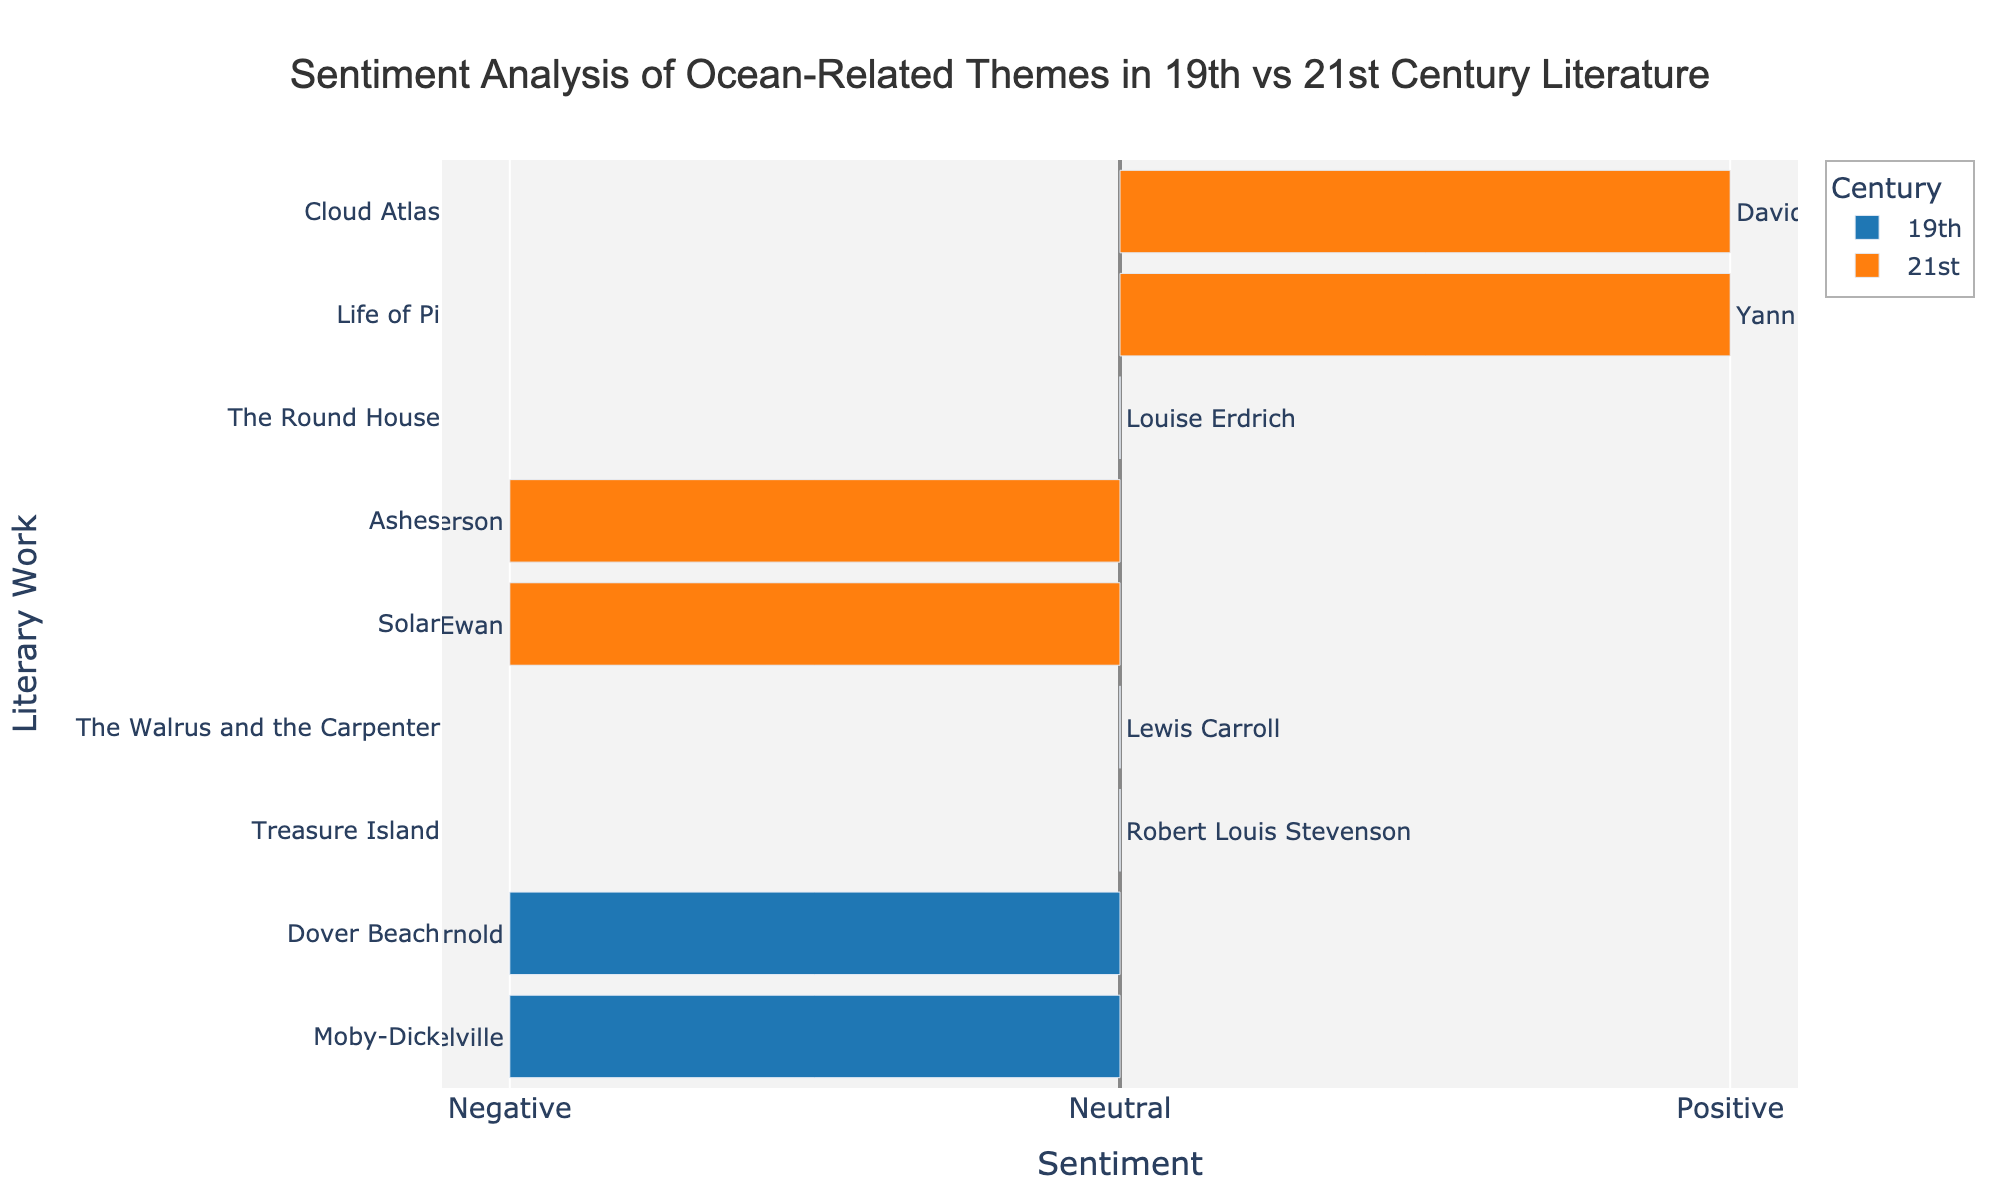What is the sentiment of "Moby-Dick"? "Moby-Dick" is represented on the chart with a bar extending to the left side of the origin point, indicating a negative sentiment as per the plot's x-axis legend.
Answer: Negative Which 21st-century literary work has a positive sentiment? The bars for 21st-century works extending to the right (positive side) include "Life of Pi" and "Cloud Atlas."
Answer: "Life of Pi" and "Cloud Atlas" Are there any 21st-century works with a neutral sentiment? Yes, the 21st-century work "The Round House" has a bar at the neutral point on the x-axis, indicating a neutral sentiment.
Answer: "The Round House" Compare the sentiments of "Moby-Dick" and "Life of Pi". Which has a more positive sentiment? "Moby-Dick" has a bar extending to the left indicating negative sentiment, whereas "Life of Pi" has a bar extending to the right indicating positive sentiment. "Life of Pi" thus has a more positive sentiment.
Answer: "Life of Pi" What is the total number of literary works from the 19th century? By counting the unique bars (works) labeled for the 19th century on the y-axis, a total of 4 works can be observed: "Moby-Dick," "Treasure Island," "Dover Beach," and "The Walrus and the Carpenter."
Answer: 4 Which century has more works with negative sentiment? Observing the bars extending to the left from the origin point, the 19th century has 2 negative works ("Moby-Dick," "Dover Beach") and the 21st century also has 2 negative works ("Solar," "Ashes"). Both centuries have an equal number of negative works.
Answer: Both centuries have equal negative works What is the average sentiment value of 21st-century literature works? 21st-century works have sentiment values of 1 ("Life of Pi"), -1 ("Solar"), 1 ("Cloud Atlas"), 0 ("The Round House"), and -1 ("Ashes"). The sum is 1 + (-1) + 1 + 0 + (-1) = 0. With 5 works, the average is 0/5 = 0.
Answer: 0 Which 19th-century work has a neutral sentiment and is also the shortest in bar length? Both "Treasure Island" and "The Walrus and the Carpenter" from the 19th century have neutral (0 sentiment) bars, and they are of the same length. Since the bars representing neutral sentiment have no width difference visually, they are equal.
Answer: "Treasure Island" and "The Walrus and the Carpenter" What is the sentiment polarity of "Solar" and "Ashes"? Both "Solar" and "Ashes" are 21st-century works with bars extending to the left, indicating negative sentiment polarity.
Answer: Negative for both 